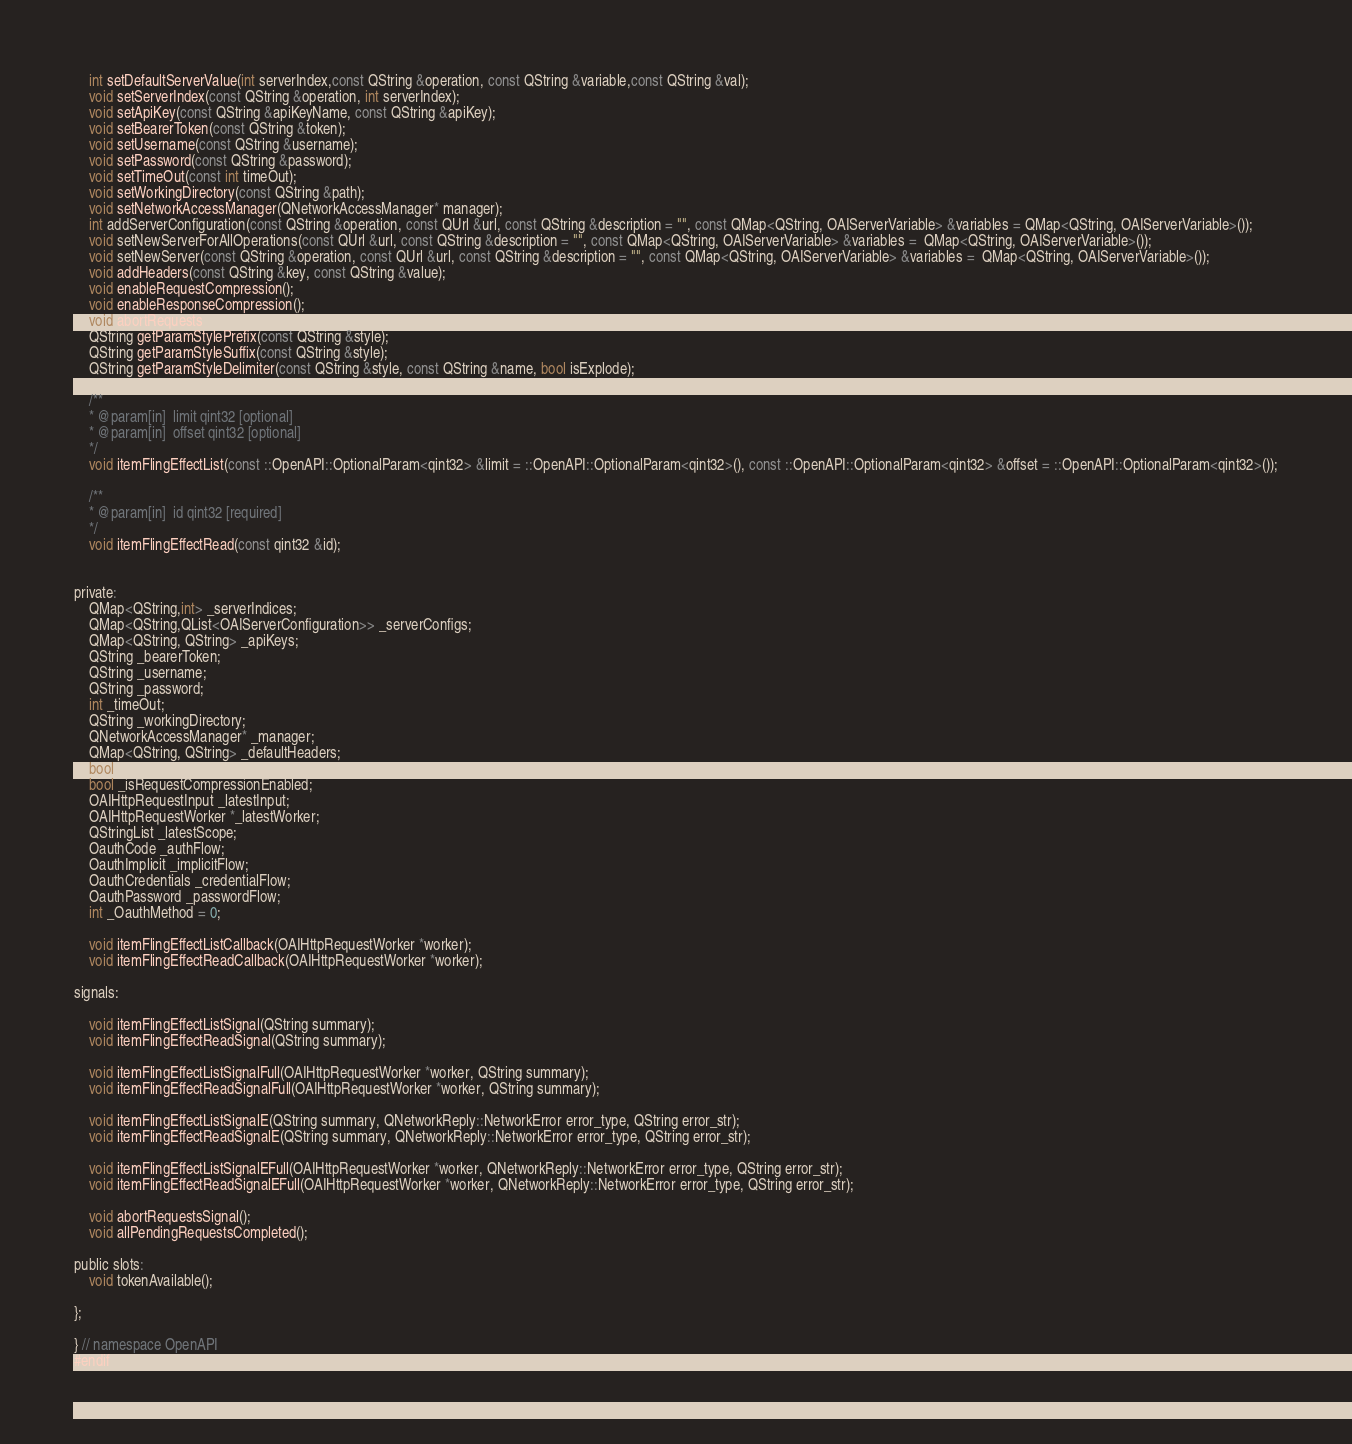<code> <loc_0><loc_0><loc_500><loc_500><_C_>    int setDefaultServerValue(int serverIndex,const QString &operation, const QString &variable,const QString &val);
    void setServerIndex(const QString &operation, int serverIndex);
    void setApiKey(const QString &apiKeyName, const QString &apiKey);
    void setBearerToken(const QString &token);
    void setUsername(const QString &username);
    void setPassword(const QString &password);
    void setTimeOut(const int timeOut);
    void setWorkingDirectory(const QString &path);
    void setNetworkAccessManager(QNetworkAccessManager* manager);
    int addServerConfiguration(const QString &operation, const QUrl &url, const QString &description = "", const QMap<QString, OAIServerVariable> &variables = QMap<QString, OAIServerVariable>());
    void setNewServerForAllOperations(const QUrl &url, const QString &description = "", const QMap<QString, OAIServerVariable> &variables =  QMap<QString, OAIServerVariable>());
    void setNewServer(const QString &operation, const QUrl &url, const QString &description = "", const QMap<QString, OAIServerVariable> &variables =  QMap<QString, OAIServerVariable>());
    void addHeaders(const QString &key, const QString &value);
    void enableRequestCompression();
    void enableResponseCompression();
    void abortRequests();
    QString getParamStylePrefix(const QString &style);
    QString getParamStyleSuffix(const QString &style);
    QString getParamStyleDelimiter(const QString &style, const QString &name, bool isExplode);

    /**
    * @param[in]  limit qint32 [optional]
    * @param[in]  offset qint32 [optional]
    */
    void itemFlingEffectList(const ::OpenAPI::OptionalParam<qint32> &limit = ::OpenAPI::OptionalParam<qint32>(), const ::OpenAPI::OptionalParam<qint32> &offset = ::OpenAPI::OptionalParam<qint32>());

    /**
    * @param[in]  id qint32 [required]
    */
    void itemFlingEffectRead(const qint32 &id);


private:
    QMap<QString,int> _serverIndices;
    QMap<QString,QList<OAIServerConfiguration>> _serverConfigs;
    QMap<QString, QString> _apiKeys;
    QString _bearerToken;
    QString _username;
    QString _password;
    int _timeOut;
    QString _workingDirectory;
    QNetworkAccessManager* _manager;
    QMap<QString, QString> _defaultHeaders;
    bool _isResponseCompressionEnabled;
    bool _isRequestCompressionEnabled;
    OAIHttpRequestInput _latestInput;
    OAIHttpRequestWorker *_latestWorker;
    QStringList _latestScope;
    OauthCode _authFlow;
    OauthImplicit _implicitFlow;
    OauthCredentials _credentialFlow;
    OauthPassword _passwordFlow;
    int _OauthMethod = 0;

    void itemFlingEffectListCallback(OAIHttpRequestWorker *worker);
    void itemFlingEffectReadCallback(OAIHttpRequestWorker *worker);

signals:

    void itemFlingEffectListSignal(QString summary);
    void itemFlingEffectReadSignal(QString summary);

    void itemFlingEffectListSignalFull(OAIHttpRequestWorker *worker, QString summary);
    void itemFlingEffectReadSignalFull(OAIHttpRequestWorker *worker, QString summary);

    void itemFlingEffectListSignalE(QString summary, QNetworkReply::NetworkError error_type, QString error_str);
    void itemFlingEffectReadSignalE(QString summary, QNetworkReply::NetworkError error_type, QString error_str);

    void itemFlingEffectListSignalEFull(OAIHttpRequestWorker *worker, QNetworkReply::NetworkError error_type, QString error_str);
    void itemFlingEffectReadSignalEFull(OAIHttpRequestWorker *worker, QNetworkReply::NetworkError error_type, QString error_str);

    void abortRequestsSignal();
    void allPendingRequestsCompleted();

public slots:
    void tokenAvailable();
    
};

} // namespace OpenAPI
#endif
</code> 